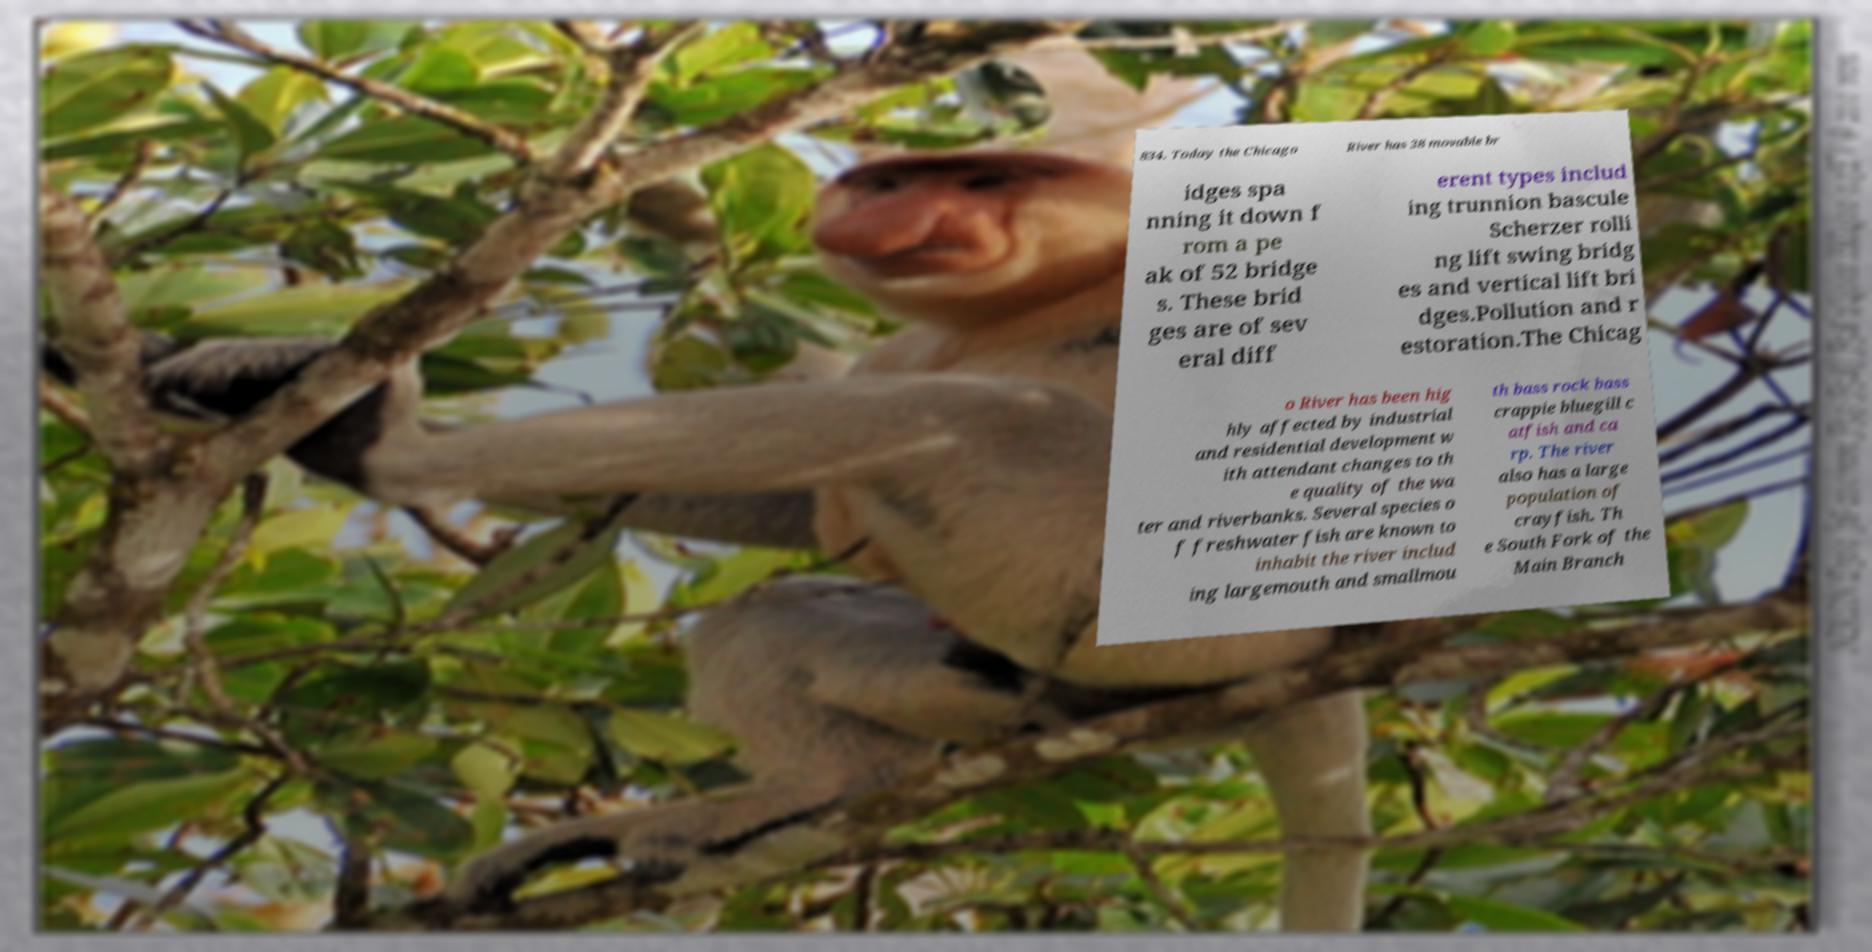Can you accurately transcribe the text from the provided image for me? 834. Today the Chicago River has 38 movable br idges spa nning it down f rom a pe ak of 52 bridge s. These brid ges are of sev eral diff erent types includ ing trunnion bascule Scherzer rolli ng lift swing bridg es and vertical lift bri dges.Pollution and r estoration.The Chicag o River has been hig hly affected by industrial and residential development w ith attendant changes to th e quality of the wa ter and riverbanks. Several species o f freshwater fish are known to inhabit the river includ ing largemouth and smallmou th bass rock bass crappie bluegill c atfish and ca rp. The river also has a large population of crayfish. Th e South Fork of the Main Branch 